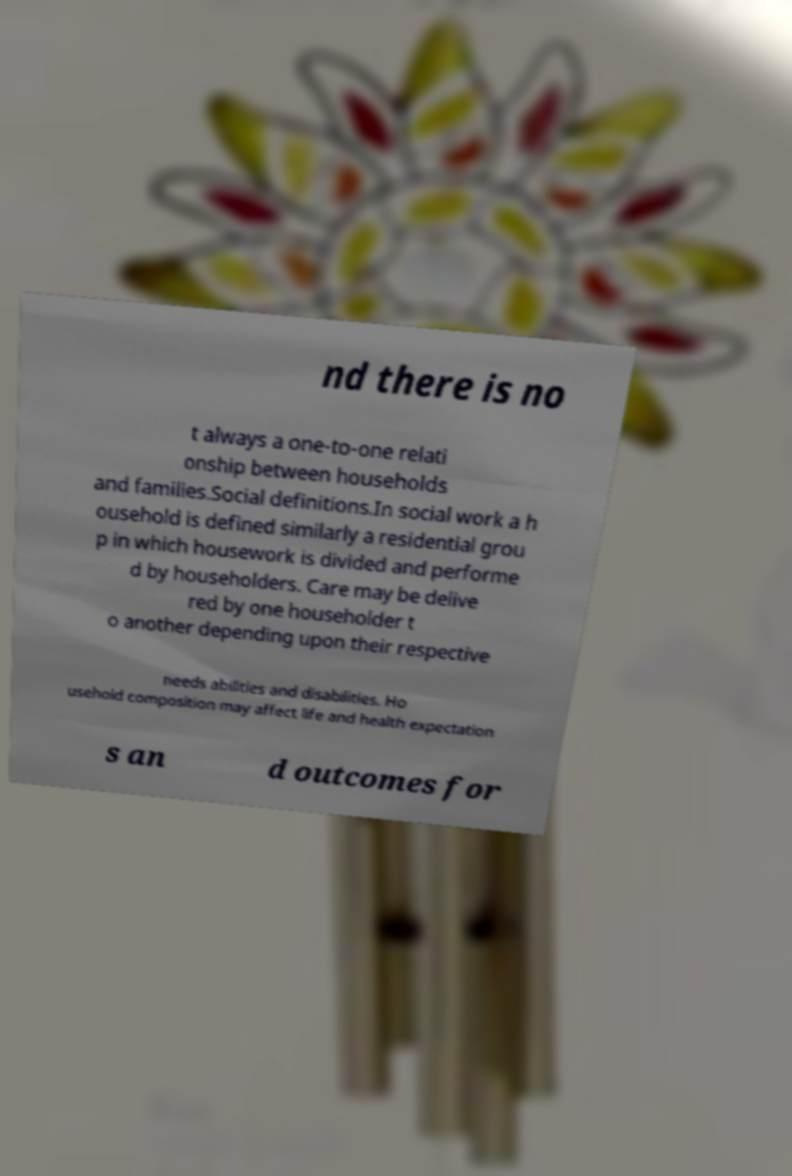Can you read and provide the text displayed in the image?This photo seems to have some interesting text. Can you extract and type it out for me? nd there is no t always a one-to-one relati onship between households and families.Social definitions.In social work a h ousehold is defined similarly a residential grou p in which housework is divided and performe d by householders. Care may be delive red by one householder t o another depending upon their respective needs abilities and disabilities. Ho usehold composition may affect life and health expectation s an d outcomes for 